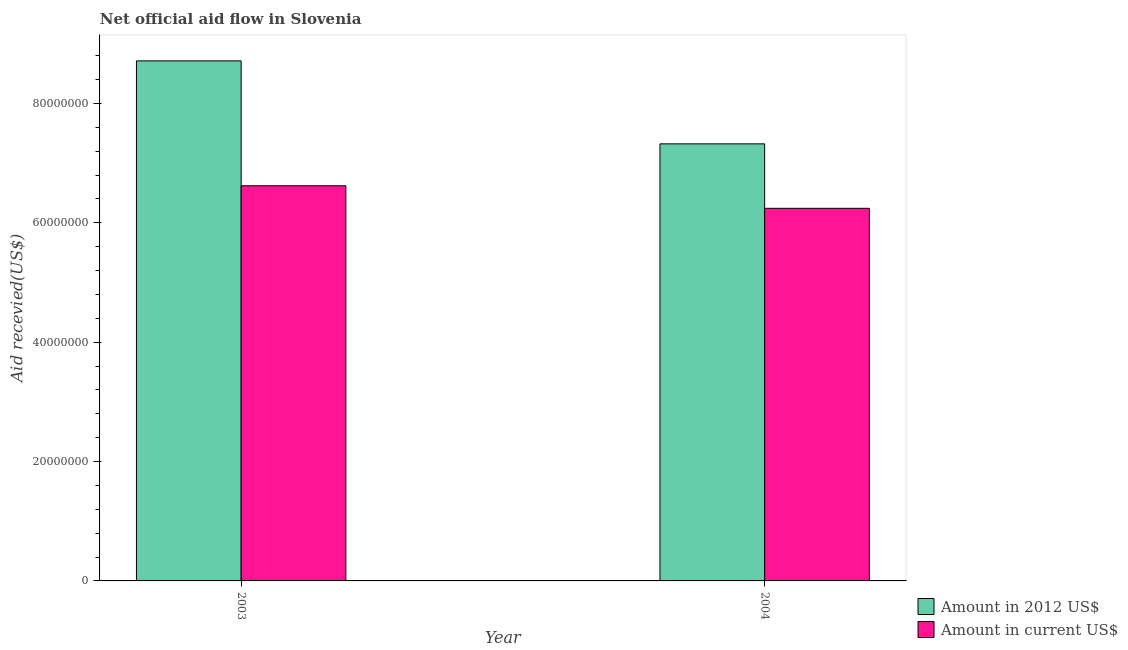How many groups of bars are there?
Your response must be concise. 2. Are the number of bars per tick equal to the number of legend labels?
Ensure brevity in your answer.  Yes. In how many cases, is the number of bars for a given year not equal to the number of legend labels?
Give a very brief answer. 0. What is the amount of aid received(expressed in us$) in 2004?
Your answer should be compact. 6.24e+07. Across all years, what is the maximum amount of aid received(expressed in us$)?
Your answer should be compact. 6.62e+07. Across all years, what is the minimum amount of aid received(expressed in us$)?
Provide a succinct answer. 6.24e+07. In which year was the amount of aid received(expressed in us$) maximum?
Give a very brief answer. 2003. What is the total amount of aid received(expressed in us$) in the graph?
Provide a succinct answer. 1.29e+08. What is the difference between the amount of aid received(expressed in 2012 us$) in 2003 and that in 2004?
Provide a succinct answer. 1.39e+07. What is the difference between the amount of aid received(expressed in 2012 us$) in 2003 and the amount of aid received(expressed in us$) in 2004?
Your answer should be compact. 1.39e+07. What is the average amount of aid received(expressed in us$) per year?
Offer a very short reply. 6.43e+07. In the year 2003, what is the difference between the amount of aid received(expressed in 2012 us$) and amount of aid received(expressed in us$)?
Your response must be concise. 0. In how many years, is the amount of aid received(expressed in us$) greater than 28000000 US$?
Give a very brief answer. 2. What is the ratio of the amount of aid received(expressed in 2012 us$) in 2003 to that in 2004?
Ensure brevity in your answer.  1.19. Is the amount of aid received(expressed in 2012 us$) in 2003 less than that in 2004?
Your answer should be compact. No. What does the 2nd bar from the left in 2003 represents?
Provide a succinct answer. Amount in current US$. What does the 2nd bar from the right in 2004 represents?
Offer a terse response. Amount in 2012 US$. Are the values on the major ticks of Y-axis written in scientific E-notation?
Keep it short and to the point. No. Does the graph contain any zero values?
Ensure brevity in your answer.  No. Does the graph contain grids?
Your response must be concise. No. Where does the legend appear in the graph?
Keep it short and to the point. Bottom right. How many legend labels are there?
Give a very brief answer. 2. What is the title of the graph?
Provide a succinct answer. Net official aid flow in Slovenia. What is the label or title of the X-axis?
Provide a short and direct response. Year. What is the label or title of the Y-axis?
Keep it short and to the point. Aid recevied(US$). What is the Aid recevied(US$) of Amount in 2012 US$ in 2003?
Offer a very short reply. 8.71e+07. What is the Aid recevied(US$) in Amount in current US$ in 2003?
Offer a very short reply. 6.62e+07. What is the Aid recevied(US$) in Amount in 2012 US$ in 2004?
Your answer should be very brief. 7.32e+07. What is the Aid recevied(US$) of Amount in current US$ in 2004?
Give a very brief answer. 6.24e+07. Across all years, what is the maximum Aid recevied(US$) of Amount in 2012 US$?
Make the answer very short. 8.71e+07. Across all years, what is the maximum Aid recevied(US$) in Amount in current US$?
Your response must be concise. 6.62e+07. Across all years, what is the minimum Aid recevied(US$) in Amount in 2012 US$?
Your answer should be compact. 7.32e+07. Across all years, what is the minimum Aid recevied(US$) of Amount in current US$?
Your answer should be compact. 6.24e+07. What is the total Aid recevied(US$) of Amount in 2012 US$ in the graph?
Provide a short and direct response. 1.60e+08. What is the total Aid recevied(US$) in Amount in current US$ in the graph?
Your answer should be compact. 1.29e+08. What is the difference between the Aid recevied(US$) in Amount in 2012 US$ in 2003 and that in 2004?
Your answer should be compact. 1.39e+07. What is the difference between the Aid recevied(US$) of Amount in current US$ in 2003 and that in 2004?
Provide a short and direct response. 3.78e+06. What is the difference between the Aid recevied(US$) of Amount in 2012 US$ in 2003 and the Aid recevied(US$) of Amount in current US$ in 2004?
Give a very brief answer. 2.47e+07. What is the average Aid recevied(US$) in Amount in 2012 US$ per year?
Make the answer very short. 8.02e+07. What is the average Aid recevied(US$) of Amount in current US$ per year?
Your answer should be very brief. 6.43e+07. In the year 2003, what is the difference between the Aid recevied(US$) of Amount in 2012 US$ and Aid recevied(US$) of Amount in current US$?
Provide a succinct answer. 2.09e+07. In the year 2004, what is the difference between the Aid recevied(US$) of Amount in 2012 US$ and Aid recevied(US$) of Amount in current US$?
Offer a very short reply. 1.08e+07. What is the ratio of the Aid recevied(US$) in Amount in 2012 US$ in 2003 to that in 2004?
Offer a terse response. 1.19. What is the ratio of the Aid recevied(US$) in Amount in current US$ in 2003 to that in 2004?
Offer a very short reply. 1.06. What is the difference between the highest and the second highest Aid recevied(US$) of Amount in 2012 US$?
Give a very brief answer. 1.39e+07. What is the difference between the highest and the second highest Aid recevied(US$) in Amount in current US$?
Make the answer very short. 3.78e+06. What is the difference between the highest and the lowest Aid recevied(US$) in Amount in 2012 US$?
Give a very brief answer. 1.39e+07. What is the difference between the highest and the lowest Aid recevied(US$) in Amount in current US$?
Make the answer very short. 3.78e+06. 